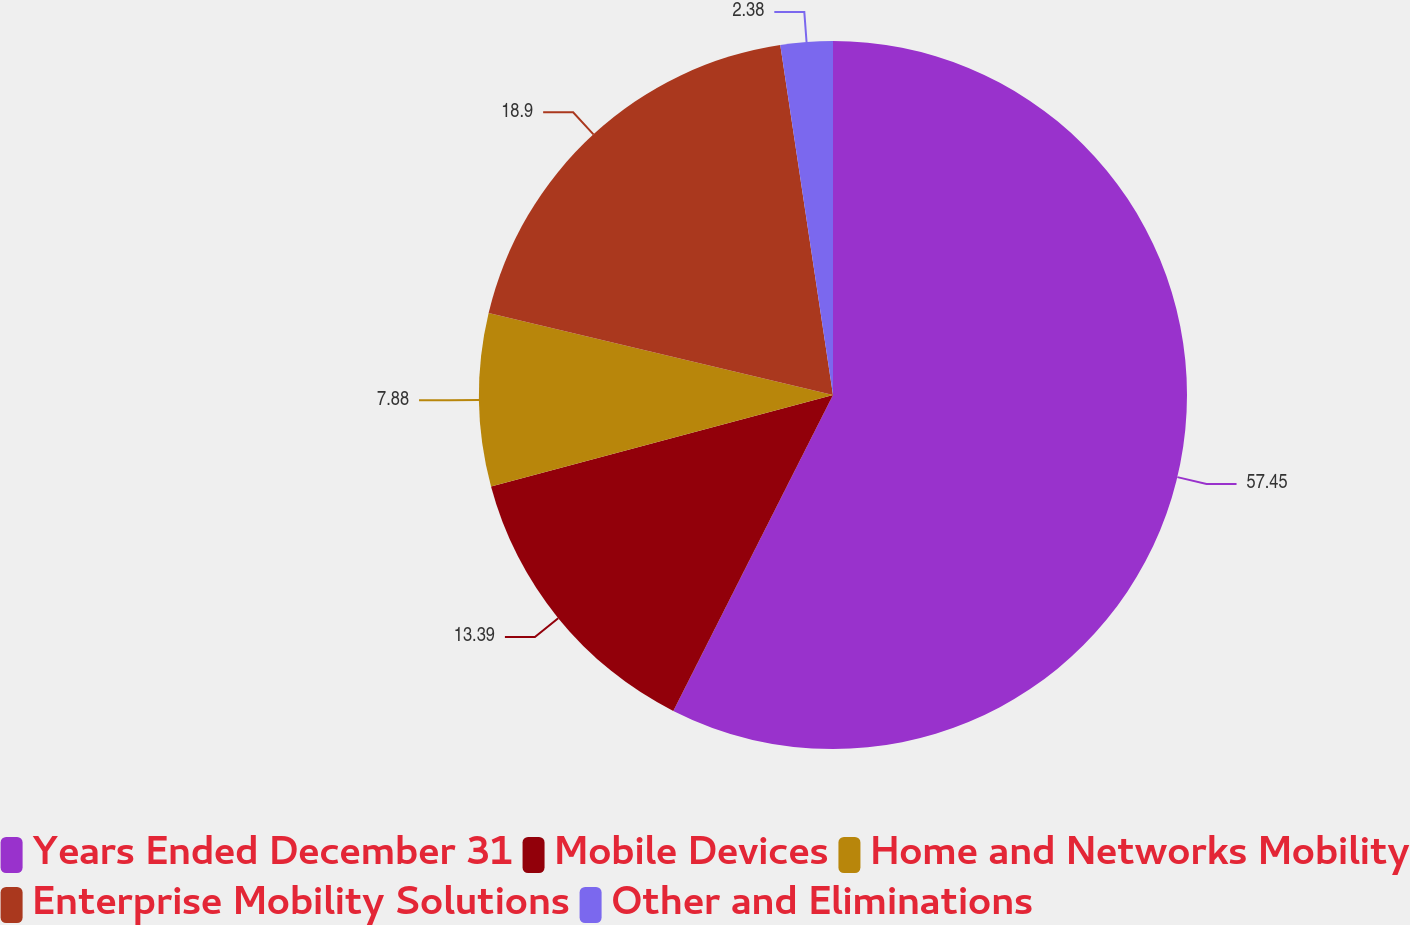Convert chart to OTSL. <chart><loc_0><loc_0><loc_500><loc_500><pie_chart><fcel>Years Ended December 31<fcel>Mobile Devices<fcel>Home and Networks Mobility<fcel>Enterprise Mobility Solutions<fcel>Other and Eliminations<nl><fcel>57.45%<fcel>13.39%<fcel>7.88%<fcel>18.9%<fcel>2.38%<nl></chart> 